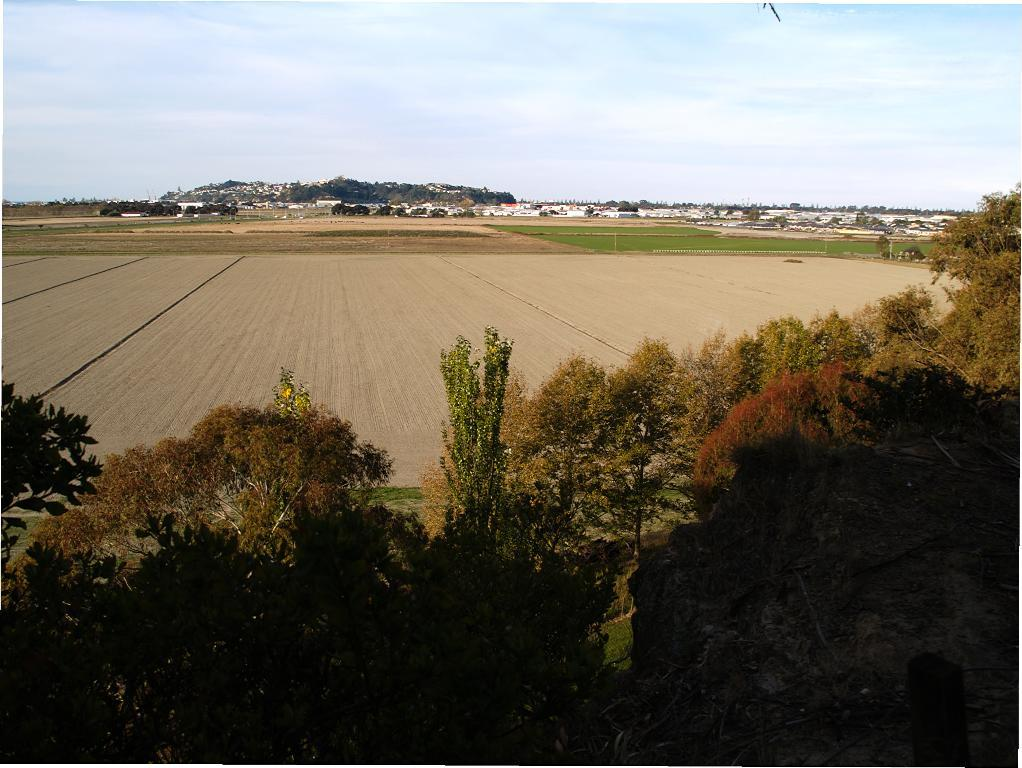What type of natural elements can be seen in the image? There are trees and a mountain in the image. What type of surface is visible in the image? There is a plane surface in the image. What type of man-made structures can be seen in the image? There are buildings in the backdrop of the image. What is the condition of the mountain in the image? The mountain is covered. What is the condition of the sky in the image? The sky is clear in the image. What is the title of the book that the mountain is reading in the image? There is no book or mountain reading a book in the image. 